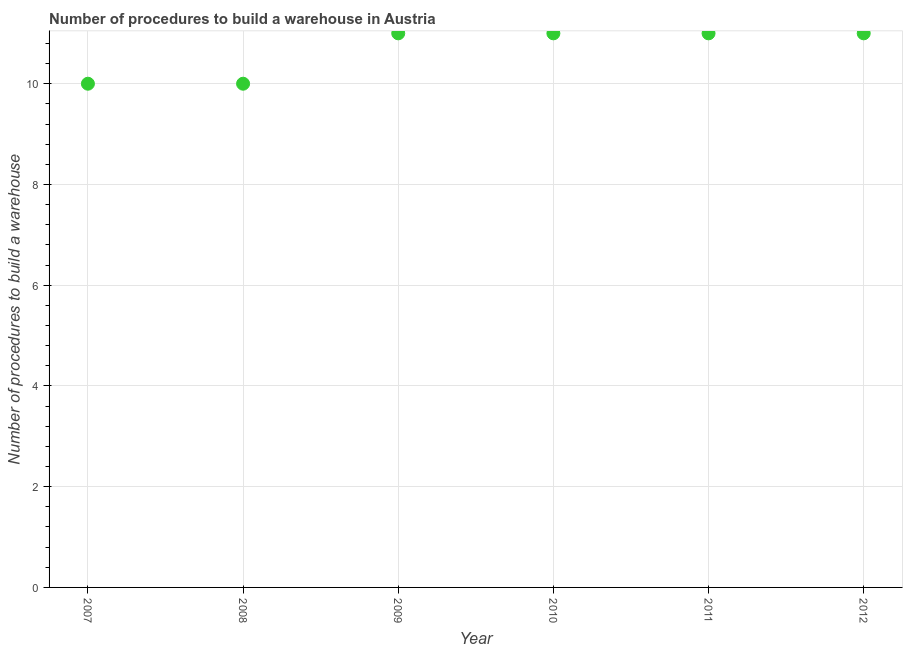What is the number of procedures to build a warehouse in 2008?
Ensure brevity in your answer.  10. Across all years, what is the maximum number of procedures to build a warehouse?
Your answer should be very brief. 11. Across all years, what is the minimum number of procedures to build a warehouse?
Offer a very short reply. 10. What is the sum of the number of procedures to build a warehouse?
Your answer should be compact. 64. What is the difference between the number of procedures to build a warehouse in 2010 and 2011?
Give a very brief answer. 0. What is the average number of procedures to build a warehouse per year?
Offer a terse response. 10.67. What is the ratio of the number of procedures to build a warehouse in 2011 to that in 2012?
Your answer should be compact. 1. Is the number of procedures to build a warehouse in 2009 less than that in 2010?
Offer a terse response. No. Is the difference between the number of procedures to build a warehouse in 2008 and 2012 greater than the difference between any two years?
Keep it short and to the point. Yes. What is the difference between the highest and the second highest number of procedures to build a warehouse?
Provide a short and direct response. 0. Is the sum of the number of procedures to build a warehouse in 2007 and 2012 greater than the maximum number of procedures to build a warehouse across all years?
Give a very brief answer. Yes. What is the difference between the highest and the lowest number of procedures to build a warehouse?
Provide a short and direct response. 1. How many dotlines are there?
Provide a succinct answer. 1. Are the values on the major ticks of Y-axis written in scientific E-notation?
Make the answer very short. No. Does the graph contain grids?
Offer a very short reply. Yes. What is the title of the graph?
Offer a very short reply. Number of procedures to build a warehouse in Austria. What is the label or title of the X-axis?
Offer a terse response. Year. What is the label or title of the Y-axis?
Keep it short and to the point. Number of procedures to build a warehouse. What is the Number of procedures to build a warehouse in 2011?
Offer a very short reply. 11. What is the difference between the Number of procedures to build a warehouse in 2007 and 2009?
Provide a short and direct response. -1. What is the difference between the Number of procedures to build a warehouse in 2007 and 2011?
Provide a short and direct response. -1. What is the difference between the Number of procedures to build a warehouse in 2008 and 2012?
Provide a succinct answer. -1. What is the difference between the Number of procedures to build a warehouse in 2009 and 2010?
Give a very brief answer. 0. What is the difference between the Number of procedures to build a warehouse in 2009 and 2011?
Offer a very short reply. 0. What is the difference between the Number of procedures to build a warehouse in 2009 and 2012?
Ensure brevity in your answer.  0. What is the difference between the Number of procedures to build a warehouse in 2010 and 2011?
Your answer should be very brief. 0. What is the difference between the Number of procedures to build a warehouse in 2010 and 2012?
Your answer should be compact. 0. What is the ratio of the Number of procedures to build a warehouse in 2007 to that in 2009?
Provide a short and direct response. 0.91. What is the ratio of the Number of procedures to build a warehouse in 2007 to that in 2010?
Provide a short and direct response. 0.91. What is the ratio of the Number of procedures to build a warehouse in 2007 to that in 2011?
Your answer should be very brief. 0.91. What is the ratio of the Number of procedures to build a warehouse in 2007 to that in 2012?
Offer a very short reply. 0.91. What is the ratio of the Number of procedures to build a warehouse in 2008 to that in 2009?
Ensure brevity in your answer.  0.91. What is the ratio of the Number of procedures to build a warehouse in 2008 to that in 2010?
Ensure brevity in your answer.  0.91. What is the ratio of the Number of procedures to build a warehouse in 2008 to that in 2011?
Your response must be concise. 0.91. What is the ratio of the Number of procedures to build a warehouse in 2008 to that in 2012?
Keep it short and to the point. 0.91. What is the ratio of the Number of procedures to build a warehouse in 2009 to that in 2010?
Give a very brief answer. 1. What is the ratio of the Number of procedures to build a warehouse in 2010 to that in 2011?
Your answer should be compact. 1. What is the ratio of the Number of procedures to build a warehouse in 2010 to that in 2012?
Keep it short and to the point. 1. What is the ratio of the Number of procedures to build a warehouse in 2011 to that in 2012?
Provide a succinct answer. 1. 